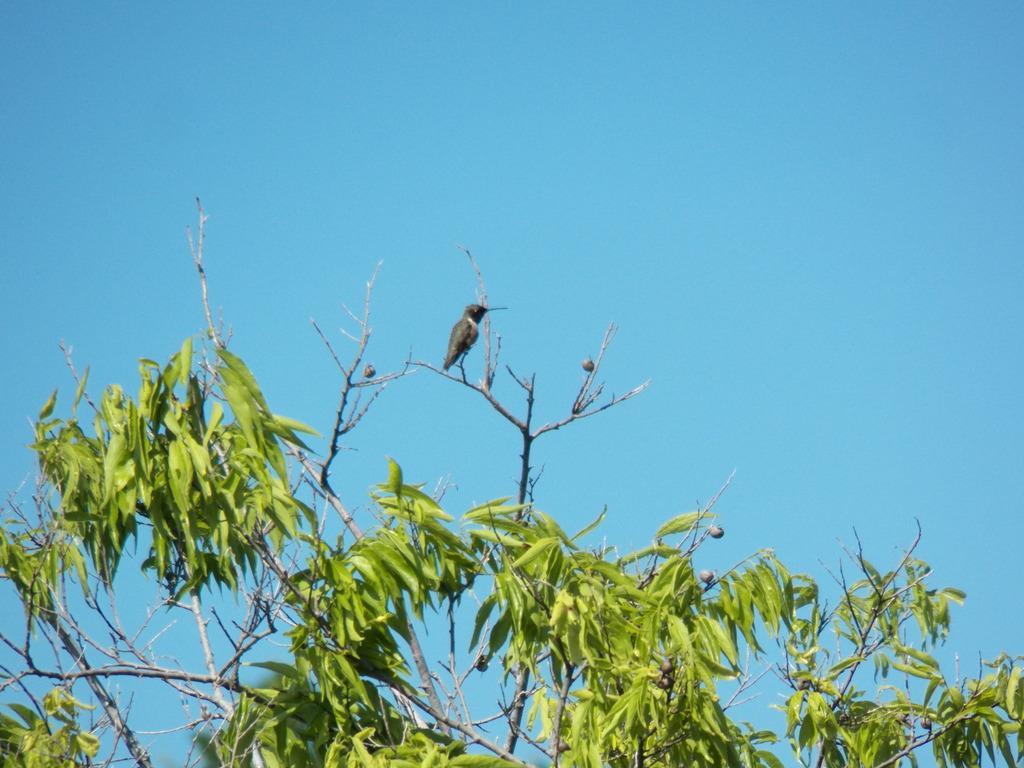Can you describe this image briefly? In this image a bird is standing on the branch of a tree having few leaves and fruits. In background there is sky. 